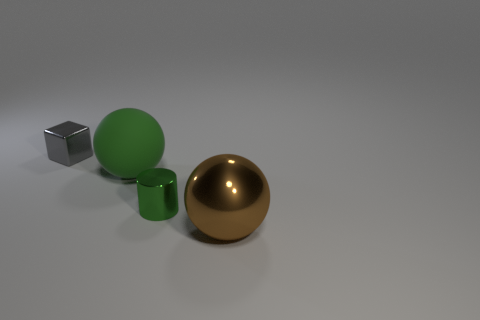The metallic object that is both behind the big metallic sphere and in front of the gray shiny cube is what color?
Provide a short and direct response. Green. Are there more big yellow metal cubes than green metal things?
Offer a terse response. No. There is a tiny thing that is right of the gray object; does it have the same shape as the gray metal thing?
Provide a short and direct response. No. How many metallic objects are either cylinders or large brown things?
Your response must be concise. 2. Are there any other big brown spheres that have the same material as the brown ball?
Provide a succinct answer. No. What is the material of the green ball?
Keep it short and to the point. Rubber. What shape is the tiny thing that is right of the shiny object behind the tiny thing that is in front of the small metal cube?
Your answer should be very brief. Cylinder. Is the number of big balls in front of the small green thing greater than the number of tiny green metallic cylinders?
Offer a very short reply. No. There is a large brown object; is it the same shape as the big thing that is behind the big shiny sphere?
Provide a short and direct response. Yes. There is another object that is the same color as the matte thing; what is its shape?
Offer a very short reply. Cylinder. 